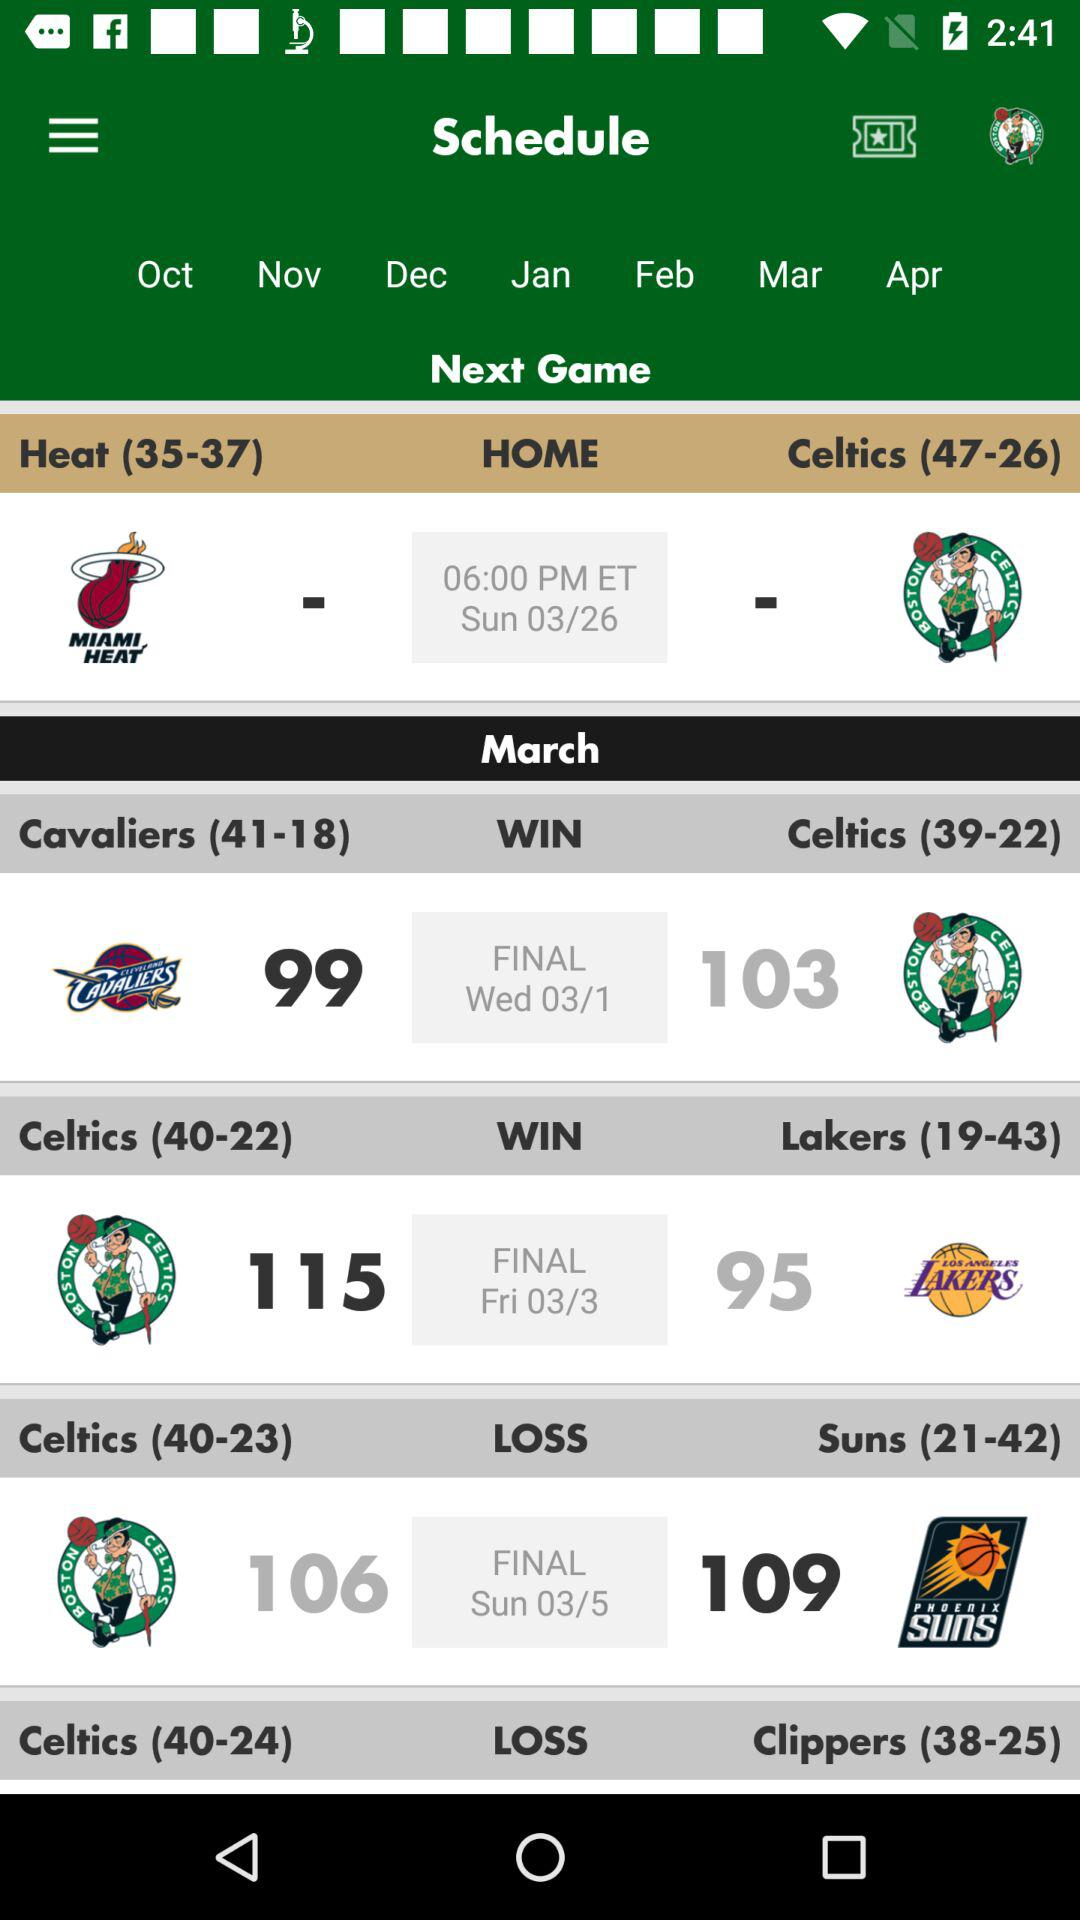What is the match result between the Celtics and Suns? The match results between the Celtics and Suns are 106-109. 